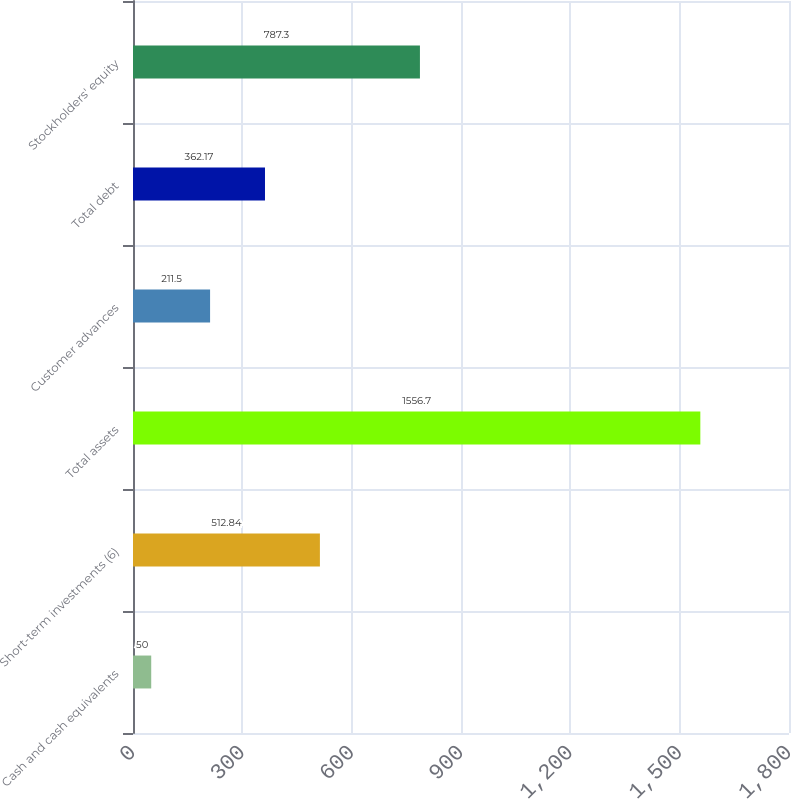Convert chart. <chart><loc_0><loc_0><loc_500><loc_500><bar_chart><fcel>Cash and cash equivalents<fcel>Short-term investments (6)<fcel>Total assets<fcel>Customer advances<fcel>Total debt<fcel>Stockholders' equity<nl><fcel>50<fcel>512.84<fcel>1556.7<fcel>211.5<fcel>362.17<fcel>787.3<nl></chart> 